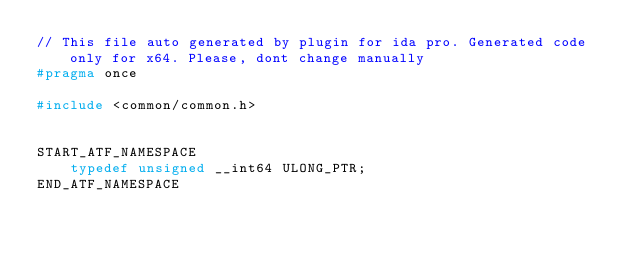<code> <loc_0><loc_0><loc_500><loc_500><_C++_>// This file auto generated by plugin for ida pro. Generated code only for x64. Please, dont change manually
#pragma once

#include <common/common.h>


START_ATF_NAMESPACE
    typedef unsigned __int64 ULONG_PTR;
END_ATF_NAMESPACE
</code> 